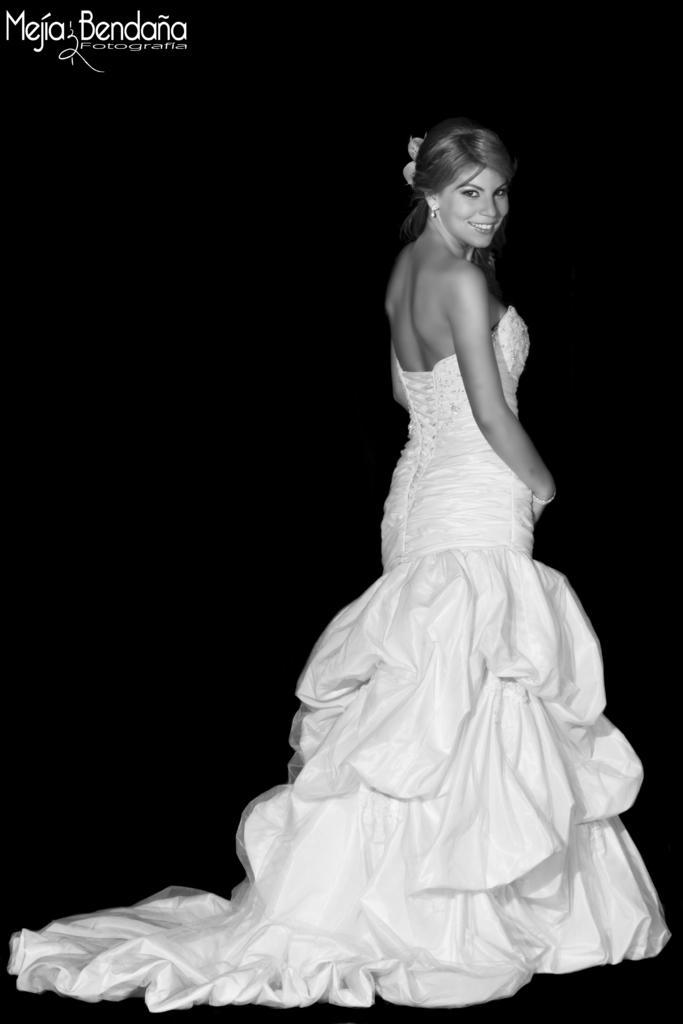In one or two sentences, can you explain what this image depicts? In this picture I can see a woman wearing a wedding dress. 